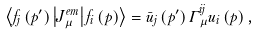<formula> <loc_0><loc_0><loc_500><loc_500>\left \langle f _ { j } \left ( p ^ { \prime } \right ) \left | J _ { \mu } ^ { e m } \right | f _ { i } \left ( p \right ) \right \rangle = \bar { u } _ { j } \left ( p ^ { \prime } \right ) \Gamma _ { \mu } ^ { i j } u _ { i } \left ( p \right ) ,</formula> 